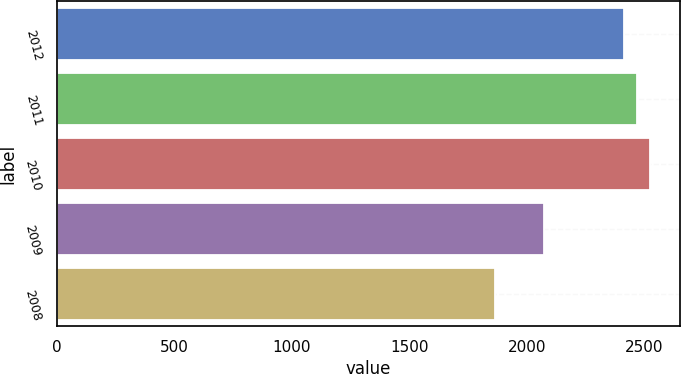Convert chart. <chart><loc_0><loc_0><loc_500><loc_500><bar_chart><fcel>2012<fcel>2011<fcel>2010<fcel>2009<fcel>2008<nl><fcel>2414<fcel>2468.8<fcel>2523.6<fcel>2075<fcel>1866<nl></chart> 